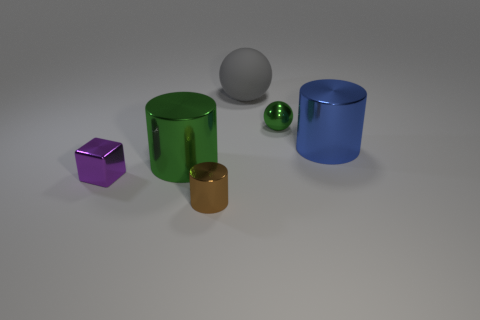What can you infer about the lighting in this scene? The scene is illuminated from above, as evidenced by the softly defined shadows directly under the objects. The consistency of the shadows indicates a single diffuse light source, possibly intended to simulate natural lighting conditions. 